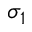Convert formula to latex. <formula><loc_0><loc_0><loc_500><loc_500>\sigma _ { 1 }</formula> 